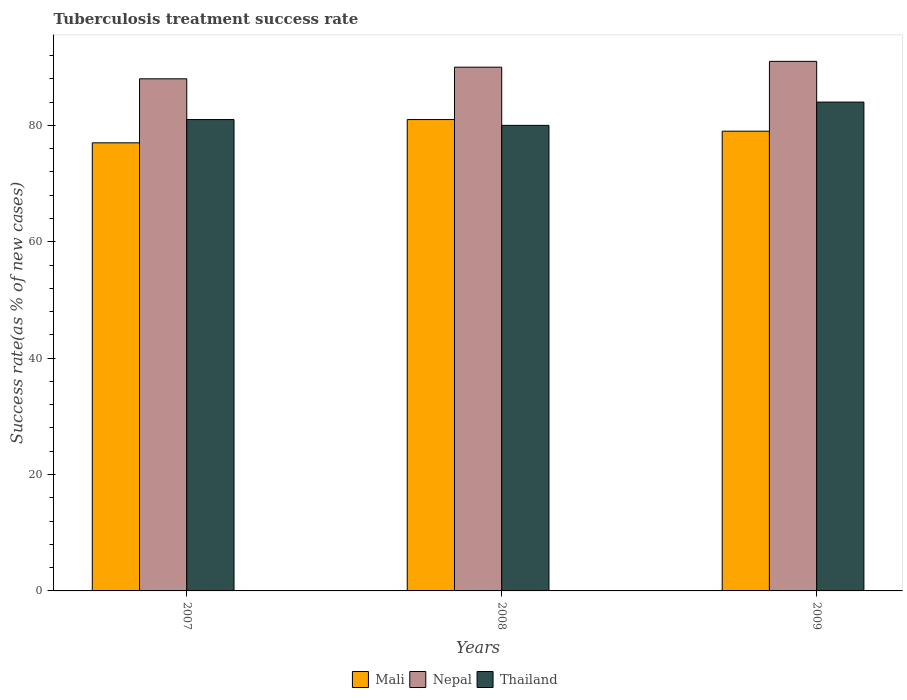How many different coloured bars are there?
Your response must be concise. 3. How many groups of bars are there?
Provide a succinct answer. 3. Are the number of bars on each tick of the X-axis equal?
Give a very brief answer. Yes. How many bars are there on the 1st tick from the right?
Your answer should be very brief. 3. Across all years, what is the maximum tuberculosis treatment success rate in Mali?
Your answer should be very brief. 81. Across all years, what is the minimum tuberculosis treatment success rate in Thailand?
Make the answer very short. 80. What is the total tuberculosis treatment success rate in Thailand in the graph?
Your answer should be compact. 245. What is the difference between the tuberculosis treatment success rate in Thailand in 2007 and that in 2008?
Offer a terse response. 1. What is the difference between the tuberculosis treatment success rate in Mali in 2007 and the tuberculosis treatment success rate in Thailand in 2008?
Keep it short and to the point. -3. What is the average tuberculosis treatment success rate in Nepal per year?
Your answer should be compact. 89.67. In the year 2009, what is the difference between the tuberculosis treatment success rate in Mali and tuberculosis treatment success rate in Nepal?
Offer a terse response. -12. In how many years, is the tuberculosis treatment success rate in Nepal greater than 64 %?
Offer a very short reply. 3. What is the ratio of the tuberculosis treatment success rate in Nepal in 2007 to that in 2008?
Provide a succinct answer. 0.98. What is the difference between the highest and the second highest tuberculosis treatment success rate in Thailand?
Provide a short and direct response. 3. What is the difference between the highest and the lowest tuberculosis treatment success rate in Nepal?
Give a very brief answer. 3. In how many years, is the tuberculosis treatment success rate in Nepal greater than the average tuberculosis treatment success rate in Nepal taken over all years?
Your answer should be very brief. 2. Is the sum of the tuberculosis treatment success rate in Nepal in 2008 and 2009 greater than the maximum tuberculosis treatment success rate in Thailand across all years?
Give a very brief answer. Yes. What does the 3rd bar from the left in 2008 represents?
Your answer should be very brief. Thailand. What does the 1st bar from the right in 2008 represents?
Give a very brief answer. Thailand. Is it the case that in every year, the sum of the tuberculosis treatment success rate in Thailand and tuberculosis treatment success rate in Nepal is greater than the tuberculosis treatment success rate in Mali?
Give a very brief answer. Yes. How many years are there in the graph?
Offer a very short reply. 3. What is the difference between two consecutive major ticks on the Y-axis?
Your response must be concise. 20. Are the values on the major ticks of Y-axis written in scientific E-notation?
Your answer should be very brief. No. Does the graph contain any zero values?
Give a very brief answer. No. Does the graph contain grids?
Your response must be concise. No. What is the title of the graph?
Offer a very short reply. Tuberculosis treatment success rate. Does "United Arab Emirates" appear as one of the legend labels in the graph?
Offer a terse response. No. What is the label or title of the Y-axis?
Make the answer very short. Success rate(as % of new cases). What is the Success rate(as % of new cases) in Mali in 2008?
Your answer should be very brief. 81. What is the Success rate(as % of new cases) of Nepal in 2008?
Ensure brevity in your answer.  90. What is the Success rate(as % of new cases) of Thailand in 2008?
Ensure brevity in your answer.  80. What is the Success rate(as % of new cases) of Mali in 2009?
Your answer should be compact. 79. What is the Success rate(as % of new cases) in Nepal in 2009?
Offer a very short reply. 91. What is the Success rate(as % of new cases) of Thailand in 2009?
Your answer should be very brief. 84. Across all years, what is the maximum Success rate(as % of new cases) of Mali?
Make the answer very short. 81. Across all years, what is the maximum Success rate(as % of new cases) in Nepal?
Your response must be concise. 91. Across all years, what is the minimum Success rate(as % of new cases) of Mali?
Offer a terse response. 77. Across all years, what is the minimum Success rate(as % of new cases) of Nepal?
Provide a short and direct response. 88. Across all years, what is the minimum Success rate(as % of new cases) of Thailand?
Make the answer very short. 80. What is the total Success rate(as % of new cases) of Mali in the graph?
Ensure brevity in your answer.  237. What is the total Success rate(as % of new cases) of Nepal in the graph?
Your response must be concise. 269. What is the total Success rate(as % of new cases) of Thailand in the graph?
Offer a terse response. 245. What is the difference between the Success rate(as % of new cases) in Mali in 2007 and that in 2008?
Provide a short and direct response. -4. What is the difference between the Success rate(as % of new cases) in Nepal in 2007 and that in 2008?
Your answer should be very brief. -2. What is the difference between the Success rate(as % of new cases) in Thailand in 2007 and that in 2008?
Your answer should be very brief. 1. What is the difference between the Success rate(as % of new cases) in Nepal in 2007 and that in 2009?
Ensure brevity in your answer.  -3. What is the difference between the Success rate(as % of new cases) of Thailand in 2007 and that in 2009?
Your response must be concise. -3. What is the difference between the Success rate(as % of new cases) of Mali in 2008 and that in 2009?
Your response must be concise. 2. What is the difference between the Success rate(as % of new cases) of Mali in 2007 and the Success rate(as % of new cases) of Nepal in 2008?
Your answer should be compact. -13. What is the difference between the Success rate(as % of new cases) in Mali in 2007 and the Success rate(as % of new cases) in Thailand in 2008?
Your response must be concise. -3. What is the difference between the Success rate(as % of new cases) of Mali in 2007 and the Success rate(as % of new cases) of Nepal in 2009?
Provide a short and direct response. -14. What is the difference between the Success rate(as % of new cases) in Mali in 2007 and the Success rate(as % of new cases) in Thailand in 2009?
Provide a short and direct response. -7. What is the difference between the Success rate(as % of new cases) of Nepal in 2007 and the Success rate(as % of new cases) of Thailand in 2009?
Keep it short and to the point. 4. What is the difference between the Success rate(as % of new cases) of Mali in 2008 and the Success rate(as % of new cases) of Thailand in 2009?
Give a very brief answer. -3. What is the difference between the Success rate(as % of new cases) of Nepal in 2008 and the Success rate(as % of new cases) of Thailand in 2009?
Your response must be concise. 6. What is the average Success rate(as % of new cases) in Mali per year?
Keep it short and to the point. 79. What is the average Success rate(as % of new cases) of Nepal per year?
Your answer should be compact. 89.67. What is the average Success rate(as % of new cases) of Thailand per year?
Offer a very short reply. 81.67. In the year 2007, what is the difference between the Success rate(as % of new cases) in Mali and Success rate(as % of new cases) in Nepal?
Offer a terse response. -11. In the year 2007, what is the difference between the Success rate(as % of new cases) in Nepal and Success rate(as % of new cases) in Thailand?
Your answer should be very brief. 7. In the year 2008, what is the difference between the Success rate(as % of new cases) of Mali and Success rate(as % of new cases) of Thailand?
Provide a succinct answer. 1. In the year 2009, what is the difference between the Success rate(as % of new cases) of Mali and Success rate(as % of new cases) of Nepal?
Offer a very short reply. -12. In the year 2009, what is the difference between the Success rate(as % of new cases) of Nepal and Success rate(as % of new cases) of Thailand?
Make the answer very short. 7. What is the ratio of the Success rate(as % of new cases) in Mali in 2007 to that in 2008?
Offer a very short reply. 0.95. What is the ratio of the Success rate(as % of new cases) in Nepal in 2007 to that in 2008?
Ensure brevity in your answer.  0.98. What is the ratio of the Success rate(as % of new cases) in Thailand in 2007 to that in 2008?
Your answer should be very brief. 1.01. What is the ratio of the Success rate(as % of new cases) of Mali in 2007 to that in 2009?
Offer a very short reply. 0.97. What is the ratio of the Success rate(as % of new cases) of Thailand in 2007 to that in 2009?
Offer a terse response. 0.96. What is the ratio of the Success rate(as % of new cases) in Mali in 2008 to that in 2009?
Your answer should be very brief. 1.03. What is the ratio of the Success rate(as % of new cases) in Thailand in 2008 to that in 2009?
Keep it short and to the point. 0.95. What is the difference between the highest and the lowest Success rate(as % of new cases) in Thailand?
Your response must be concise. 4. 